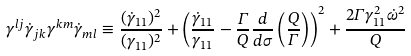<formula> <loc_0><loc_0><loc_500><loc_500>\gamma ^ { l j } \dot { \gamma } _ { j k } \gamma ^ { k m } \dot { \gamma } _ { m l } \equiv \frac { ( \dot { \gamma } _ { 1 1 } ) ^ { 2 } } { ( \gamma _ { 1 1 } ) ^ { 2 } } + \left ( \frac { \dot { \gamma } _ { 1 1 } } { \gamma _ { 1 1 } } - \frac { \Gamma } { Q } \frac { d } { d \sigma } \left ( \frac { Q } { \Gamma } \right ) \right ) ^ { 2 } + \frac { 2 \Gamma \gamma _ { 1 1 } ^ { 2 } \dot { \omega } ^ { 2 } } { Q }</formula> 